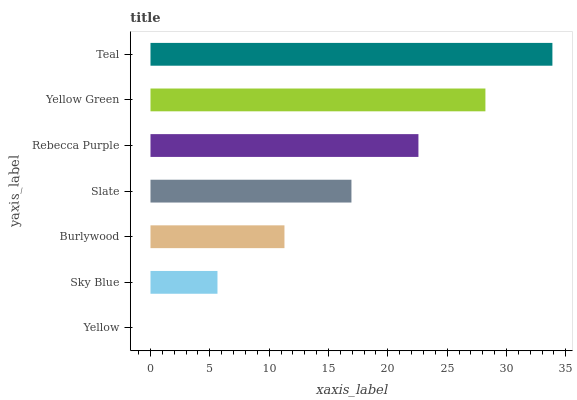Is Yellow the minimum?
Answer yes or no. Yes. Is Teal the maximum?
Answer yes or no. Yes. Is Sky Blue the minimum?
Answer yes or no. No. Is Sky Blue the maximum?
Answer yes or no. No. Is Sky Blue greater than Yellow?
Answer yes or no. Yes. Is Yellow less than Sky Blue?
Answer yes or no. Yes. Is Yellow greater than Sky Blue?
Answer yes or no. No. Is Sky Blue less than Yellow?
Answer yes or no. No. Is Slate the high median?
Answer yes or no. Yes. Is Slate the low median?
Answer yes or no. Yes. Is Sky Blue the high median?
Answer yes or no. No. Is Yellow Green the low median?
Answer yes or no. No. 